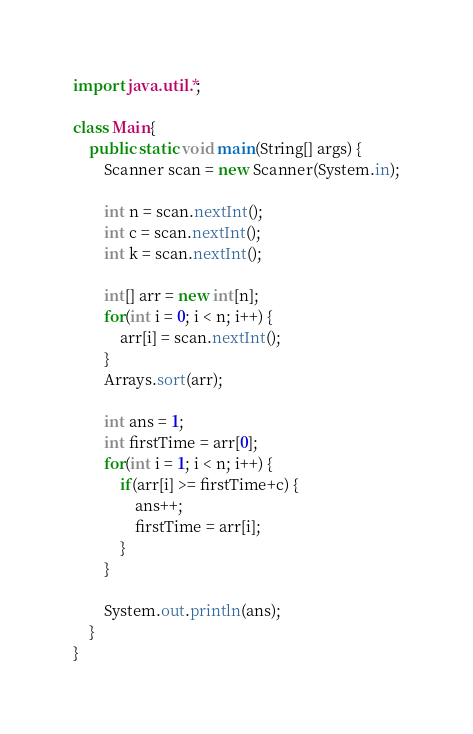<code> <loc_0><loc_0><loc_500><loc_500><_Java_>import java.util.*;

class Main{
	public static void main(String[] args) {
		Scanner scan = new Scanner(System.in);

		int n = scan.nextInt();
		int c = scan.nextInt();
		int k = scan.nextInt();

		int[] arr = new int[n];
		for(int i = 0; i < n; i++) {
			arr[i] = scan.nextInt();
		}
		Arrays.sort(arr);

		int ans = 1;
		int firstTime = arr[0];
		for(int i = 1; i < n; i++) {
			if(arr[i] >= firstTime+c) {
				ans++;
				firstTime = arr[i];
			}
		}

		System.out.println(ans);
	}
}
</code> 